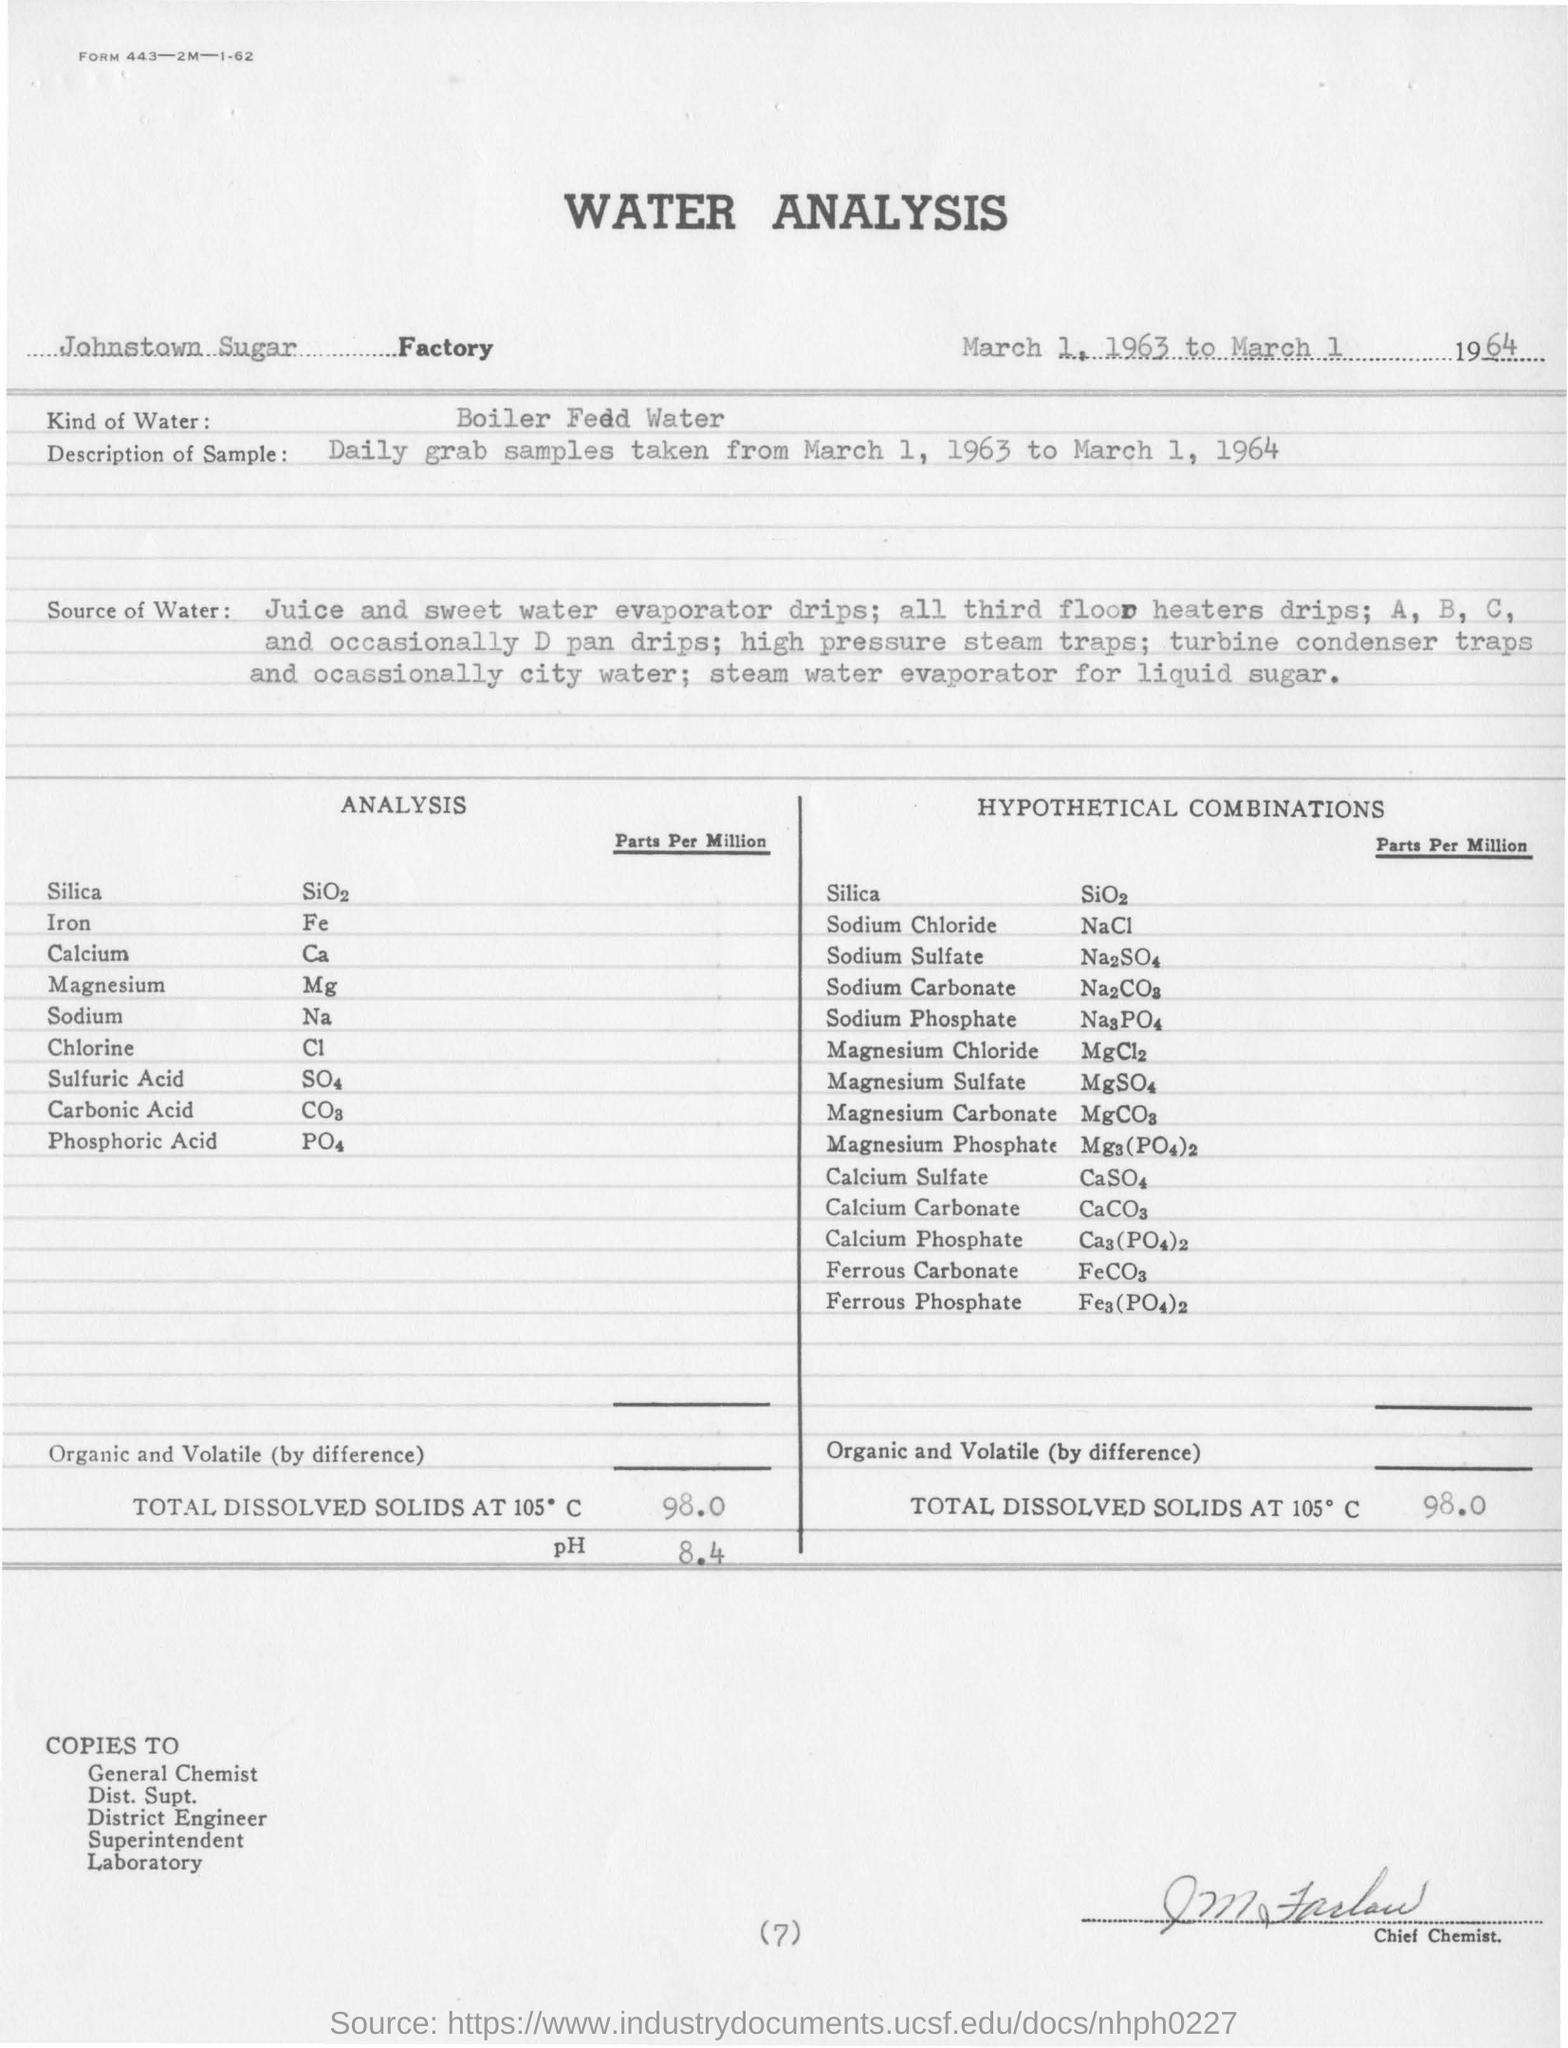Outline some significant characteristics in this image. Silica, also known as silicon dioxide, is a chemical formula represented by SiO2. The document is titled "Water Analysis. The total dissolved solids at 150 degrees Celsius is 98%. The symbol of Calcium is Ca. 